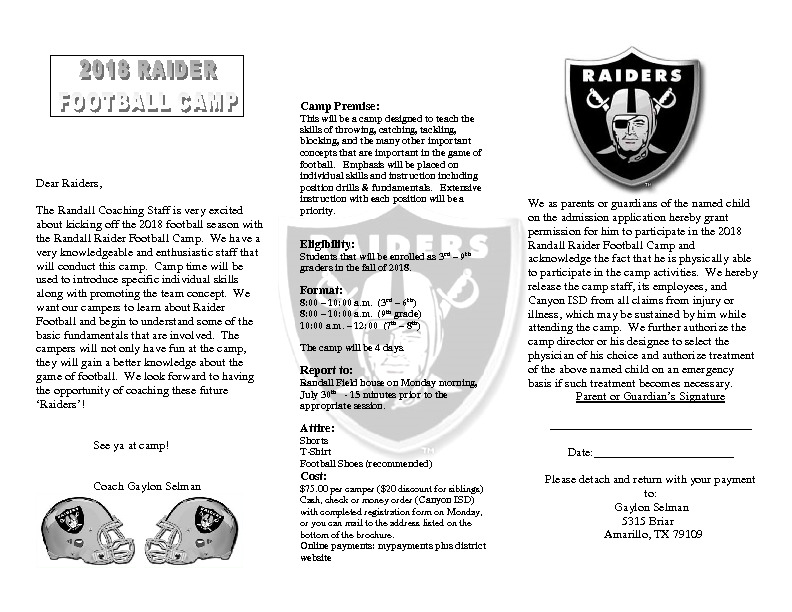Imagine if the camp also included a surprise visit from a professional football player! Who might that be and what kind of demonstration or talk could they give? Imagine the thrill if a professional football player made a surprise visit to the camp! Although the specific player remains a mystery, they could provide an unforgettable experience for the campers. The player might start with a motivational talk, sharing their journey from being a young football enthusiast to becoming a professional athlete. They could give insights on the importance of hard work, perseverance, and teamwork in achieving their dreams. Following the talk, the player could conduct a live demonstration of advanced football techniques, showing precise throws, agile footwork, and powerful tackling strategies. They could also join in on some of the drills, offering personalized tips and encouragement to the campers. This interaction would not only inspire the young athletes but also give them a firsthand glimpse into the skills and dedication required at the professional level. 